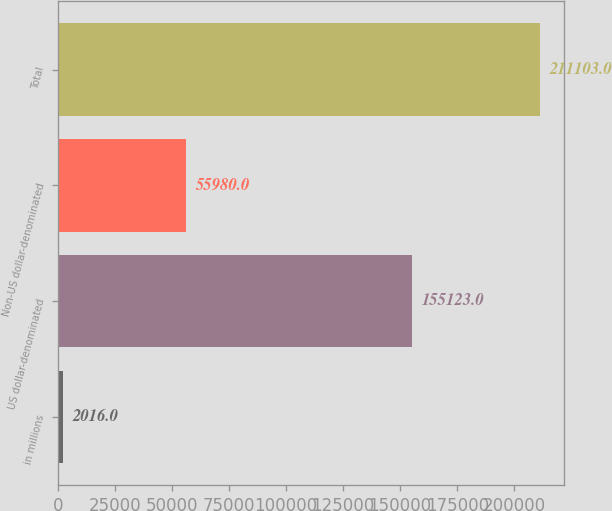<chart> <loc_0><loc_0><loc_500><loc_500><bar_chart><fcel>in millions<fcel>US dollar-denominated<fcel>Non-US dollar-denominated<fcel>Total<nl><fcel>2016<fcel>155123<fcel>55980<fcel>211103<nl></chart> 